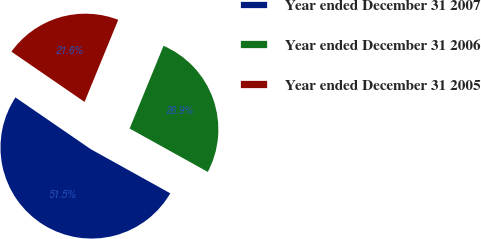Convert chart to OTSL. <chart><loc_0><loc_0><loc_500><loc_500><pie_chart><fcel>Year ended December 31 2007<fcel>Year ended December 31 2006<fcel>Year ended December 31 2005<nl><fcel>51.52%<fcel>26.87%<fcel>21.61%<nl></chart> 